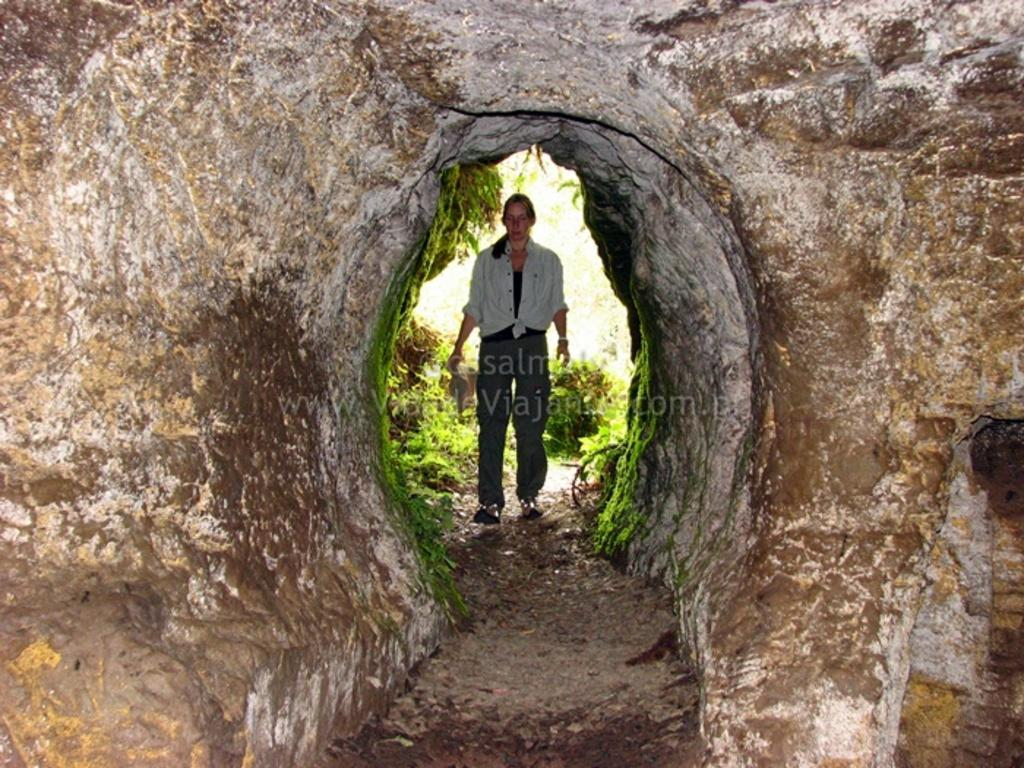What type of natural formation is present in the image? There is a cave in the image. Who is present in the image? There is a woman standing in the image. What type of vegetation can be seen in the image? There are plants in the image. What type of joke is the woman telling in the image? There is no indication in the image that the woman is telling a joke, so it cannot be determined from the picture. 